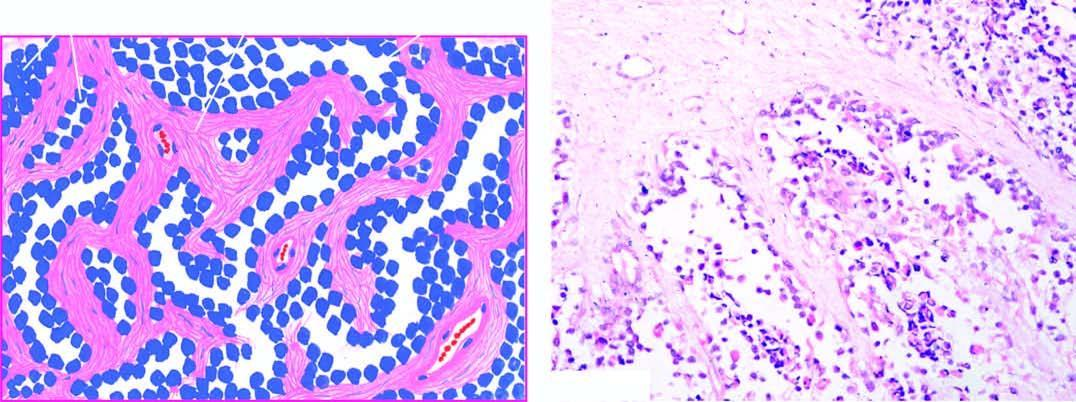what is the tumour divided into?
Answer the question using a single word or phrase. Alveolar spaces composed of fibrocollagenous tissue 